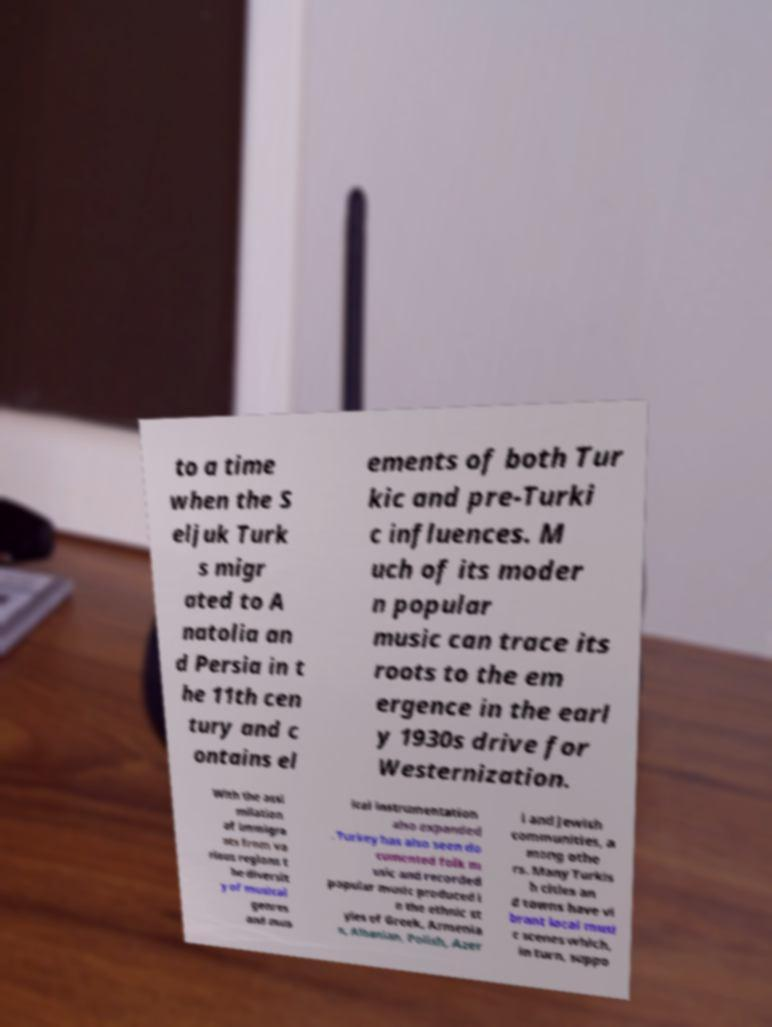Please read and relay the text visible in this image. What does it say? to a time when the S eljuk Turk s migr ated to A natolia an d Persia in t he 11th cen tury and c ontains el ements of both Tur kic and pre-Turki c influences. M uch of its moder n popular music can trace its roots to the em ergence in the earl y 1930s drive for Westernization. With the assi milation of immigra nts from va rious regions t he diversit y of musical genres and mus ical instrumentation also expanded . Turkey has also seen do cumented folk m usic and recorded popular music produced i n the ethnic st yles of Greek, Armenia n, Albanian, Polish, Azer i and Jewish communities, a mong othe rs. Many Turkis h cities an d towns have vi brant local musi c scenes which, in turn, suppo 